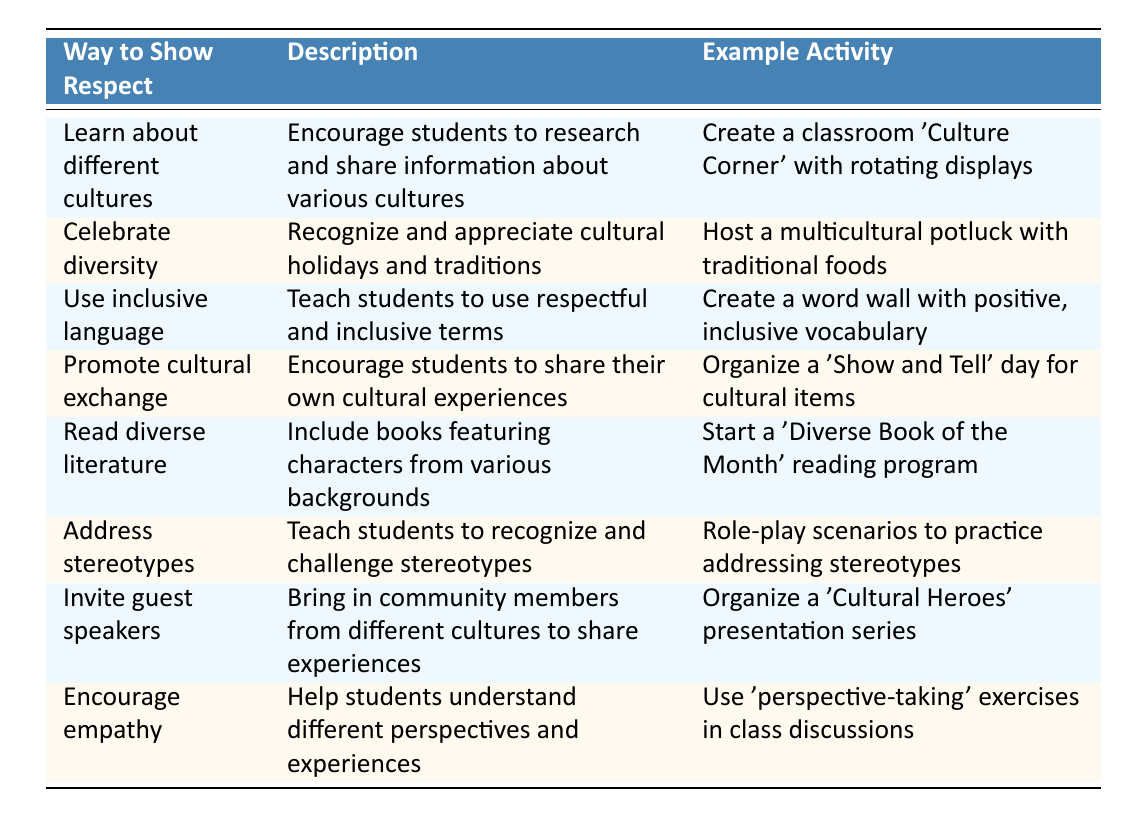What is one way to show respect for diverse cultures mentioned in the table? The table lists several ways to show respect for diverse cultures, one of them being "Learn about different cultures."
Answer: Learn about different cultures What is the example activity for promoting cultural exchange? The table states that the example activity for promoting cultural exchange is "Organize a 'Show and Tell' day for cultural items."
Answer: Organize a 'Show and Tell' day for cultural items True or false: The table suggests using exclusive language to show respect for diverse cultures. The table refers to "Use inclusive language" as a way to show respect, not exclusive language, making the statement false.
Answer: False How many ways to show respect for diverse cultures are listed in the table? The table presents a total of eight ways to show respect for diverse cultures, as indicated by the number of rows.
Answer: Eight What is an example activity associated with inviting guest speakers? According to the table, the example activity associated with inviting guest speakers is "Organize a 'Cultural Heroes' presentation series."
Answer: Organize a 'Cultural Heroes' presentation series Which way to show respect involves reading and literature? The table specifies that "Read diverse literature" is the way associated with reading and literature.
Answer: Read diverse literature What is the average number of words in the descriptions provided in the table? By counting the words in each description and dividing the total by the number of ways listed (8), we find the average. The total word count is 55, leading to an average of 6.875 words.
Answer: Approximately 6.875 words Which two ways to show respect focus on recognizing and discussing cultural differences? The two ways that emphasize recognizing and discussing cultural differences are "Address stereotypes" and "Encourage empathy," as they both involve understanding perspectives and challenging negative views.
Answer: Address stereotypes and Encourage empathy 